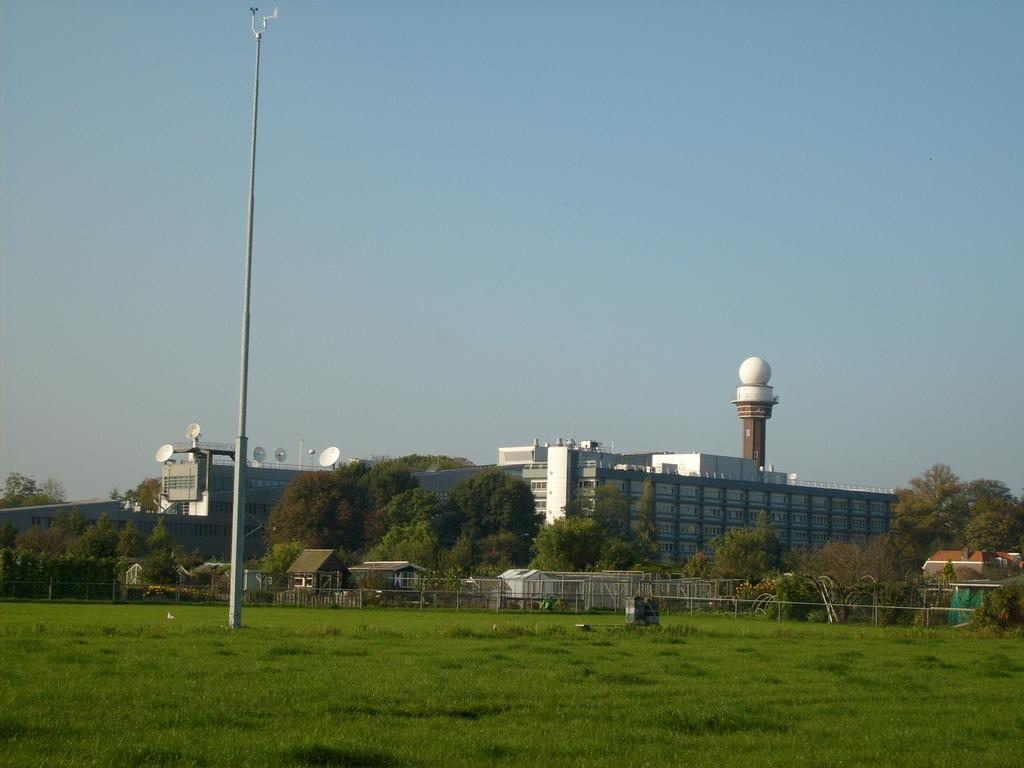What can be seen in the sky in the image? The sky is visible in the image, but no specific details about the sky can be determined from the provided facts. What type of structure is present in the image? There is a pole, buildings, a fence, and a shed in the image. What type of vegetation is present in the image? Trees are present in the image. What is the family's interest in the image? There is no family or interest present in the image; it features a sky, pole, buildings, fence, shed, and trees. What thought is being expressed by the trees in the image? Trees do not express thoughts, so this question cannot be answered definitively based on the provided facts. 